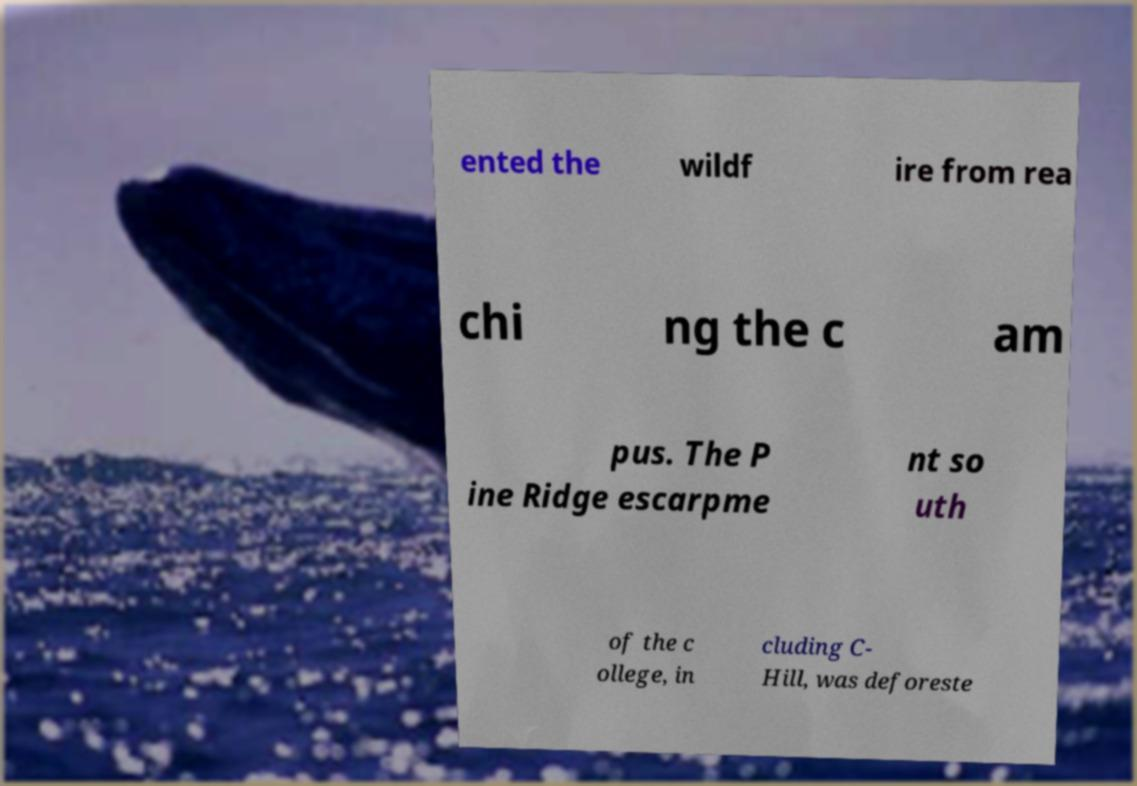There's text embedded in this image that I need extracted. Can you transcribe it verbatim? ented the wildf ire from rea chi ng the c am pus. The P ine Ridge escarpme nt so uth of the c ollege, in cluding C- Hill, was deforeste 